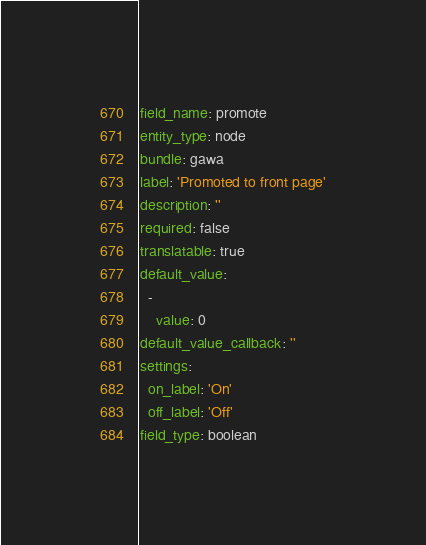Convert code to text. <code><loc_0><loc_0><loc_500><loc_500><_YAML_>field_name: promote
entity_type: node
bundle: gawa
label: 'Promoted to front page'
description: ''
required: false
translatable: true
default_value:
  -
    value: 0
default_value_callback: ''
settings:
  on_label: 'On'
  off_label: 'Off'
field_type: boolean
</code> 